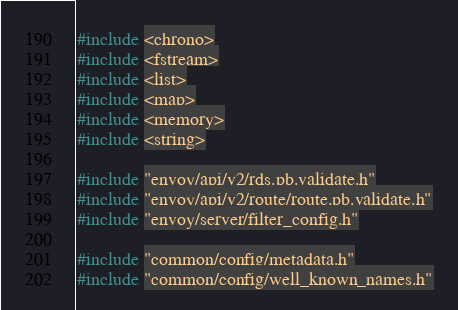Convert code to text. <code><loc_0><loc_0><loc_500><loc_500><_C++_>#include <chrono>
#include <fstream>
#include <list>
#include <map>
#include <memory>
#include <string>

#include "envoy/api/v2/rds.pb.validate.h"
#include "envoy/api/v2/route/route.pb.validate.h"
#include "envoy/server/filter_config.h"

#include "common/config/metadata.h"
#include "common/config/well_known_names.h"</code> 